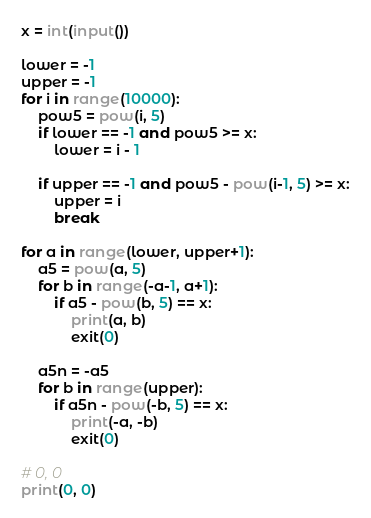Convert code to text. <code><loc_0><loc_0><loc_500><loc_500><_Python_>x = int(input())

lower = -1
upper = -1
for i in range(10000):
    pow5 = pow(i, 5)
    if lower == -1 and pow5 >= x:
        lower = i - 1

    if upper == -1 and pow5 - pow(i-1, 5) >= x:
        upper = i
        break

for a in range(lower, upper+1):
    a5 = pow(a, 5)
    for b in range(-a-1, a+1):
        if a5 - pow(b, 5) == x:
            print(a, b)
            exit(0)

    a5n = -a5
    for b in range(upper):
        if a5n - pow(-b, 5) == x:
            print(-a, -b)
            exit(0)

# 0, 0
print(0, 0)
</code> 